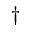Convert formula to latex. <formula><loc_0><loc_0><loc_500><loc_500>^ { \dag }</formula> 